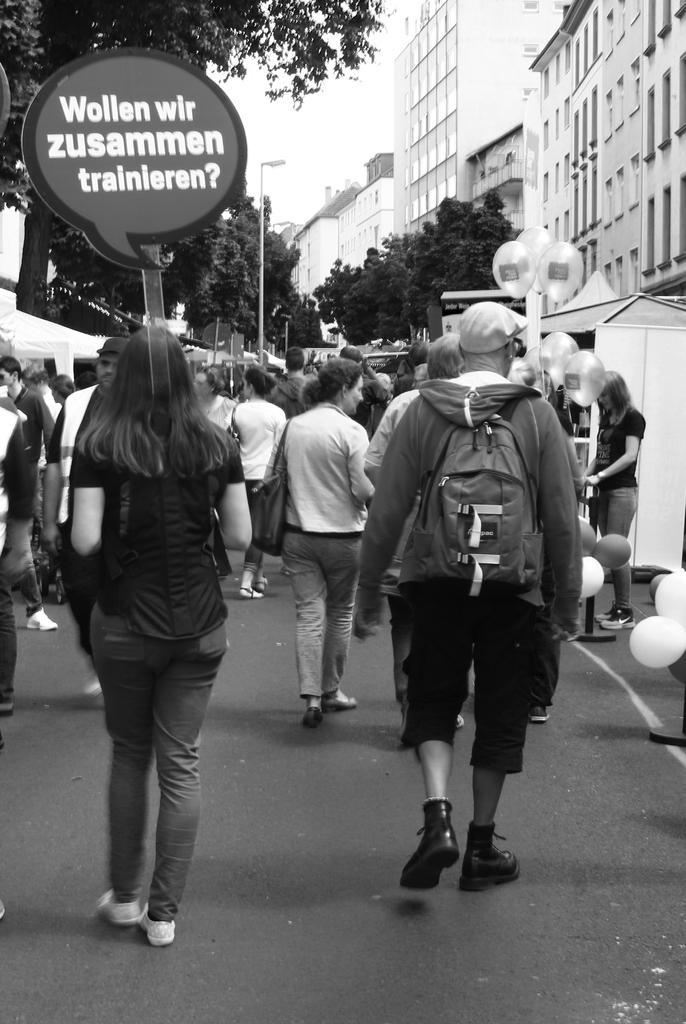In one or two sentences, can you explain what this image depicts? This is a black and white image. There are a few people, buildings, trees, poles, balloons, tents. We can see the ground and the sky. We can see a board with some text. 